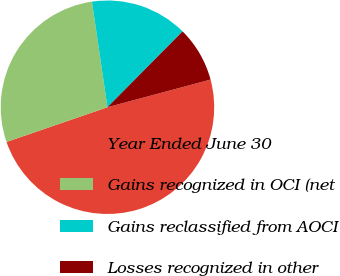Convert chart. <chart><loc_0><loc_0><loc_500><loc_500><pie_chart><fcel>Year Ended June 30<fcel>Gains recognized in OCI (net<fcel>Gains reclassified from AOCI<fcel>Losses recognized in other<nl><fcel>48.9%<fcel>27.95%<fcel>14.75%<fcel>8.4%<nl></chart> 